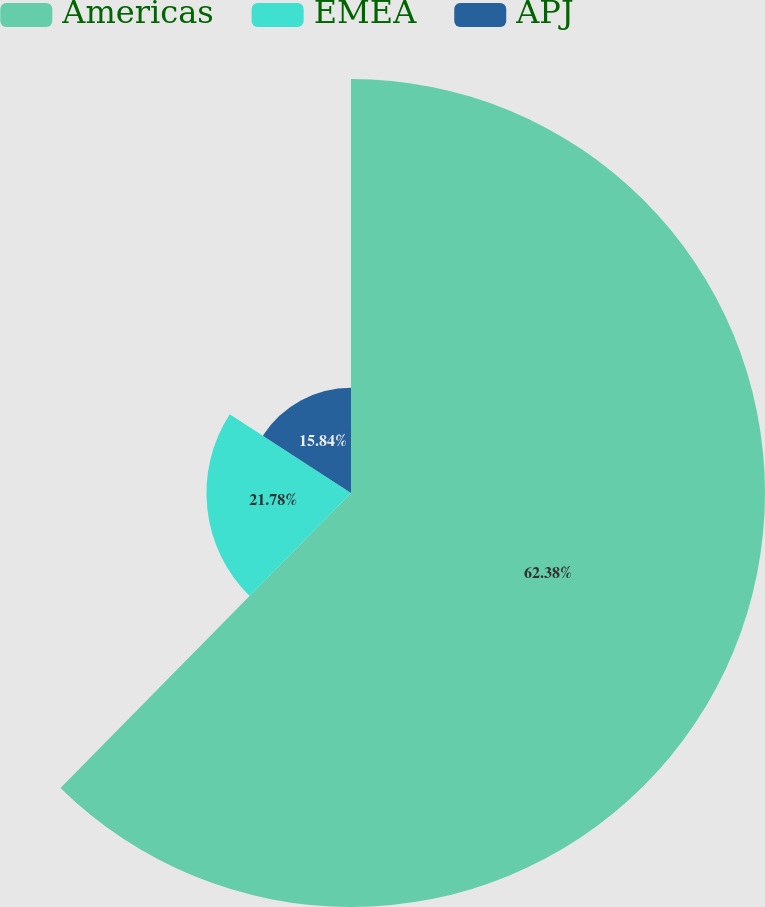Convert chart. <chart><loc_0><loc_0><loc_500><loc_500><pie_chart><fcel>Americas<fcel>EMEA<fcel>APJ<nl><fcel>62.38%<fcel>21.78%<fcel>15.84%<nl></chart> 